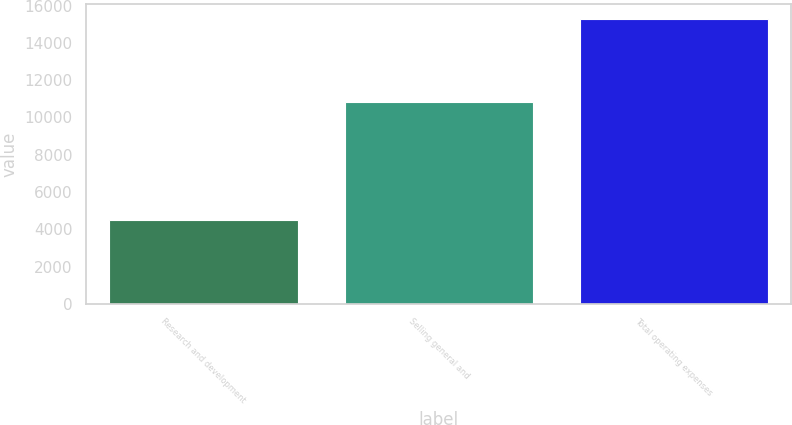Convert chart to OTSL. <chart><loc_0><loc_0><loc_500><loc_500><bar_chart><fcel>Research and development<fcel>Selling general and<fcel>Total operating expenses<nl><fcel>4475<fcel>10830<fcel>15305<nl></chart> 